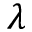<formula> <loc_0><loc_0><loc_500><loc_500>\lambda</formula> 